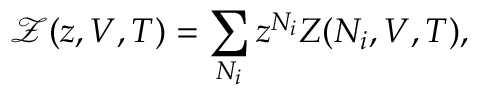Convert formula to latex. <formula><loc_0><loc_0><loc_500><loc_500>{ \mathcal { Z } } ( z , V , T ) = \sum _ { N _ { i } } z ^ { N _ { i } } Z ( N _ { i } , V , T ) ,</formula> 